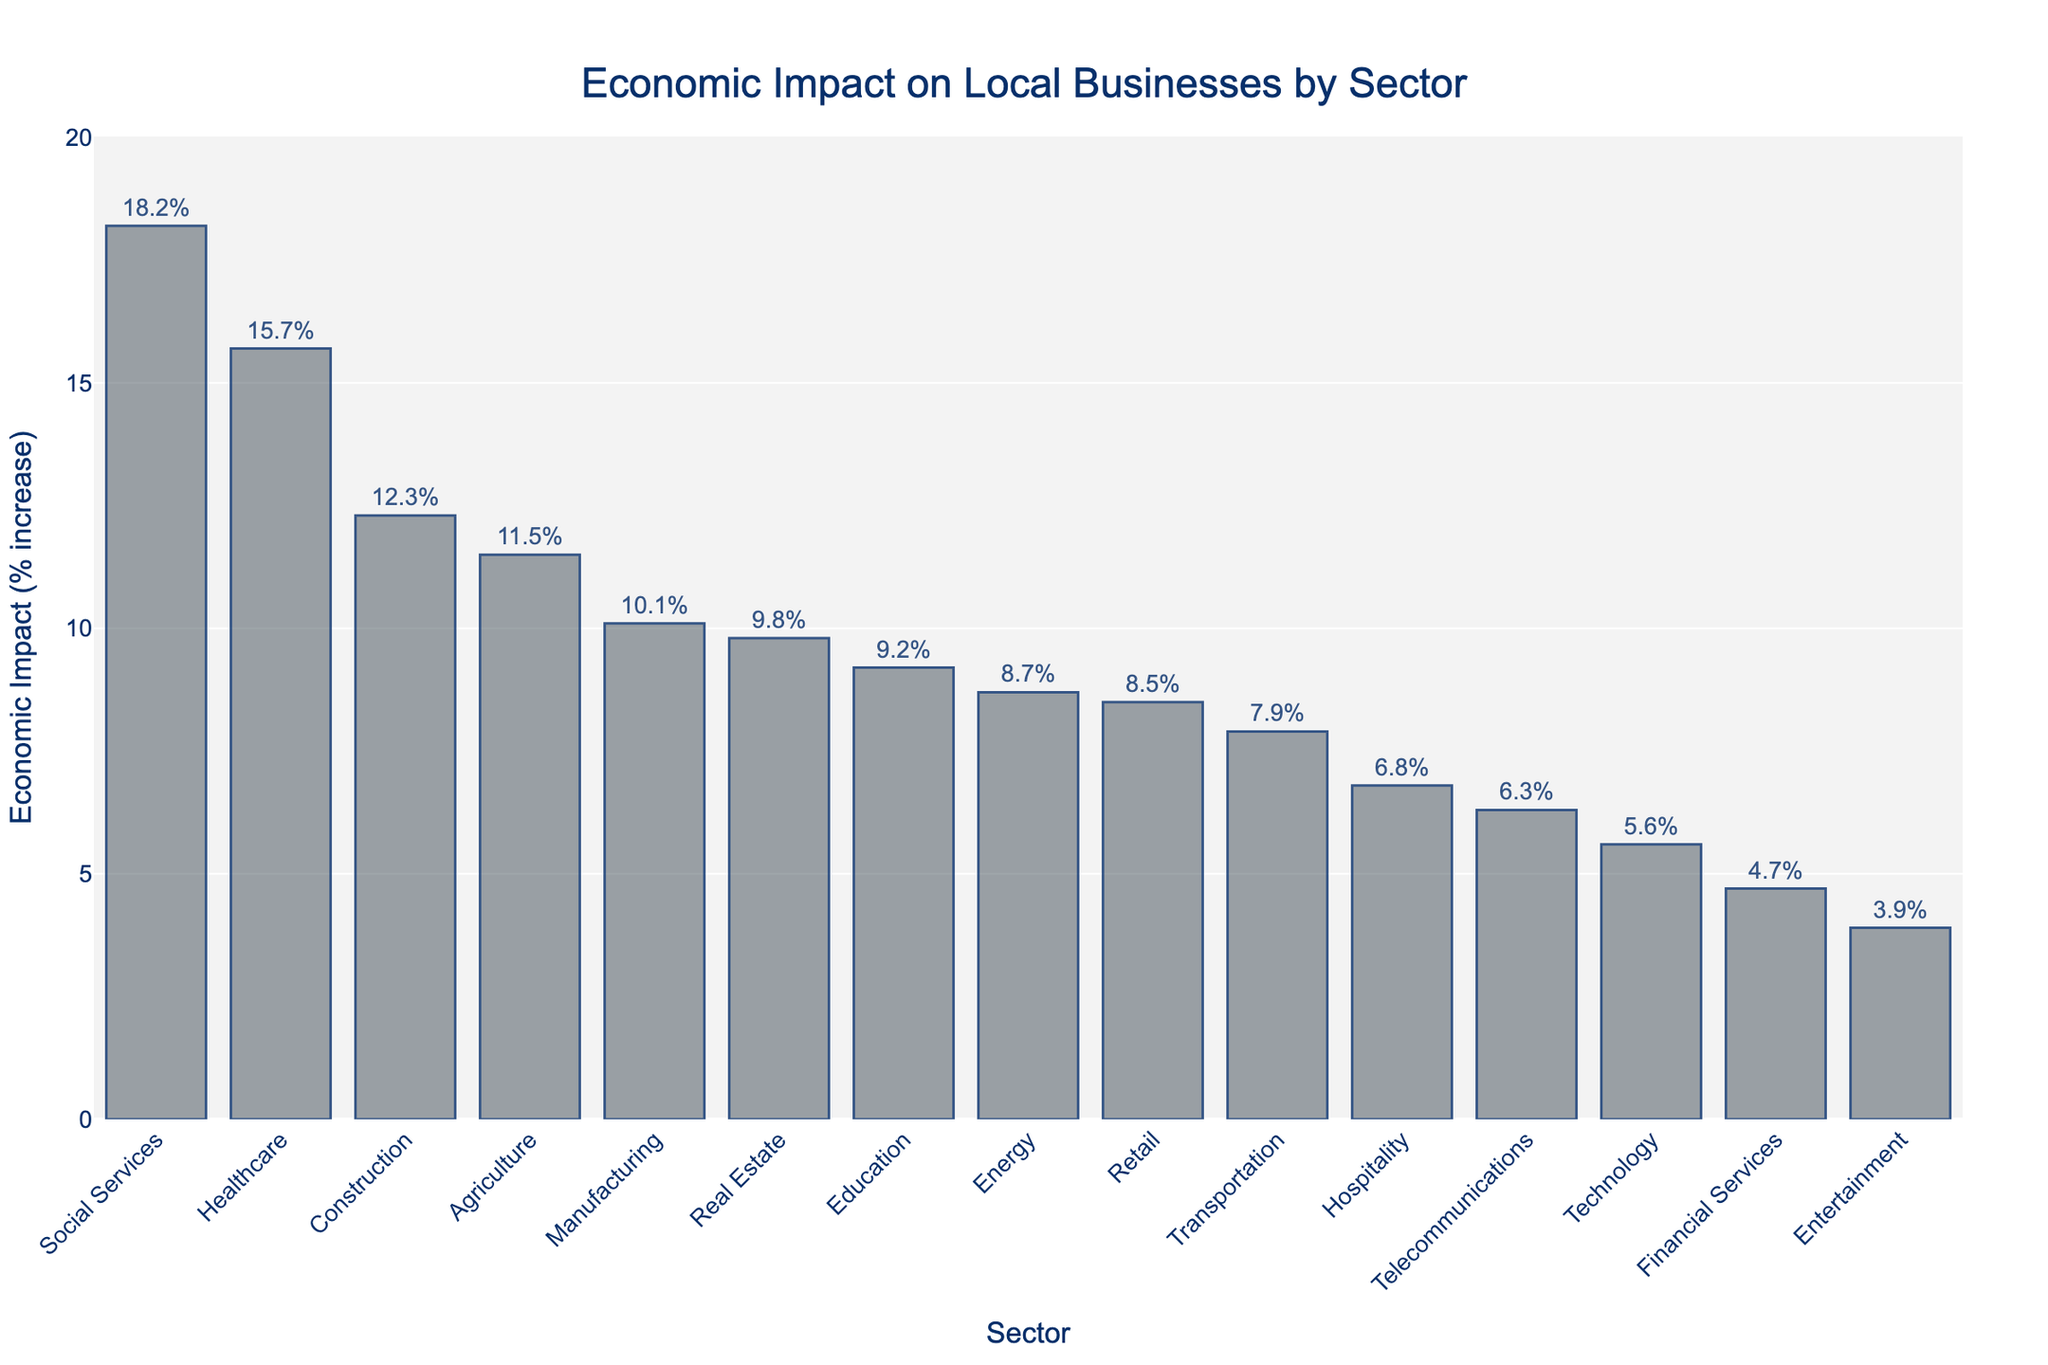Which sector has the highest economic impact? The highest bar represents the sector with the maximum economic impact. This bar belongs to Social Services.
Answer: Social Services Which sector has the second highest economic impact? The second highest bar indicates the sector with the second maximum economic impact. This bar belongs to Healthcare.
Answer: Healthcare What is the economic impact of the Technology sector? Identify the Technology sector's bar and read its corresponding value. The height of the bar represents 5.6% increase.
Answer: 5.6% How much greater is the economic impact on Healthcare compared to Technology? Subtract the economic impact of Technology (5.6%) from Healthcare (15.7%). 15.7 - 5.6 = 10.1.
Answer: 10.1% Which sectors have an economic impact of less than 6%? Identify bars with values less than 6%. These sectors are Financial Services (4.7%), Entertainment (3.9%), and Technology (5.6%).
Answer: Financial Services, Entertainment, Technology What is the average economic impact of the sectors with more than 10% impact? Identify sectors with impacts greater than 10%: Social Services (18.2%), Healthcare (15.7%), Construction (12.3%), Agriculture (11.5%), Manufacturing (10.1%). Calculate their average: (18.2 + 15.7 + 12.3 + 11.5 + 10.1)/5 = 13.56.
Answer: 13.56% Compare the economic impact of Retail and Hospitality sectors. Which one has a higher impact? The heights of the Retail and Hospitality bars are compared. Retail sector's impact is 8.5%, Hospitality's impact is 6.8%. Retail is higher.
Answer: Retail What is the difference in economic impact between the highest and lowest sectors? Subtract the lowest value (Entertainment, 3.9%) from the highest value (Social Services, 18.2%). 18.2 - 3.9 = 14.3.
Answer: 14.3% Is there any sector with an economic impact between 8% and 9%? Identify bars whose economic impact values lie between 8% and 9%. Retail (8.5%) and Energy (8.7%) fall within this range.
Answer: Retail, Energy What's the combined economic impact of the Education and Real Estate sectors? Sum the economic impacts of Education (9.2%) and Real Estate (9.8%). 9.2 + 9.8 = 19.
Answer: 19% 